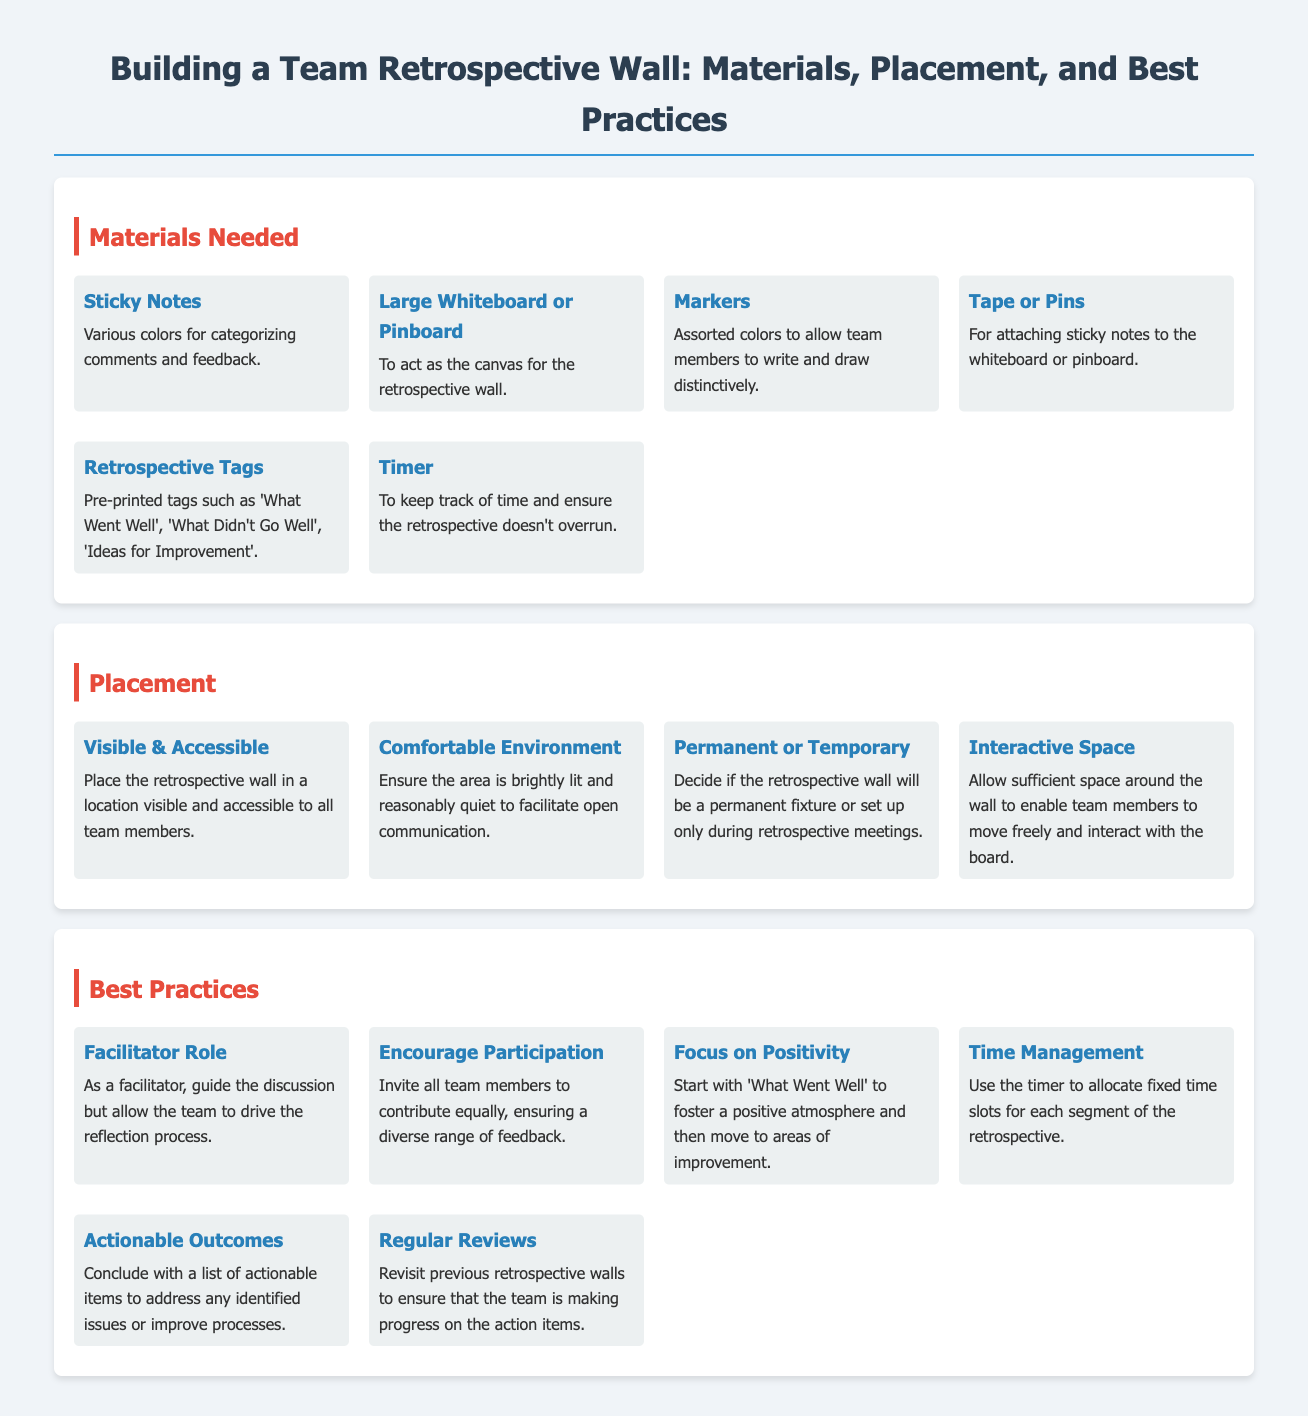What are the materials needed for the retrospective wall? The materials are listed in the document under the "Materials Needed" section, including sticky notes, a large whiteboard or pinboard, markers, tape or pins, retrospective tags, and a timer.
Answer: Sticky Notes, Large Whiteboard or Pinboard, Markers, Tape or Pins, Retrospective Tags, Timer How should the retrospective wall be placed? The placement guidelines can be found in the "Placement" section, which emphasizes the need for visibility and accessibility, a comfortable environment, interactive space, and a decision on permanence.
Answer: Visible & Accessible, Comfortable Environment, Permanent or Temporary, Interactive Space What is a recommended best practice for facilitating retrospectives? Best practices are outlined in the "Best Practices" section, with several suggestions including focusing on positivity and encouraging participation.
Answer: Facilitator Role How many items are listed under best practices? To find this, count the items mentioned in the "Best Practices" section. Each item is a separate recommendation.
Answer: Six What colors should the sticky notes be? The document states that various colors are needed for categorizing comments and feedback.
Answer: Various colors What is the purpose of the timer in the retrospective wall setup? The timer serves to keep track of time during the retrospective and ensure it doesn't overrun, as indicated in the materials and best practices.
Answer: To keep track of time What are the retrospective tags meant for? The document specifies that retrospective tags like 'What Went Well', 'What Didn't Go Well', and 'Ideas for Improvement' are used for categorizing feedback during retrospectives.
Answer: Categorizing feedback What should be done at the end of the retrospective? The document points out that concluding with a list of actionable items is recommended to address issues and improve processes.
Answer: Actionable outcomes 